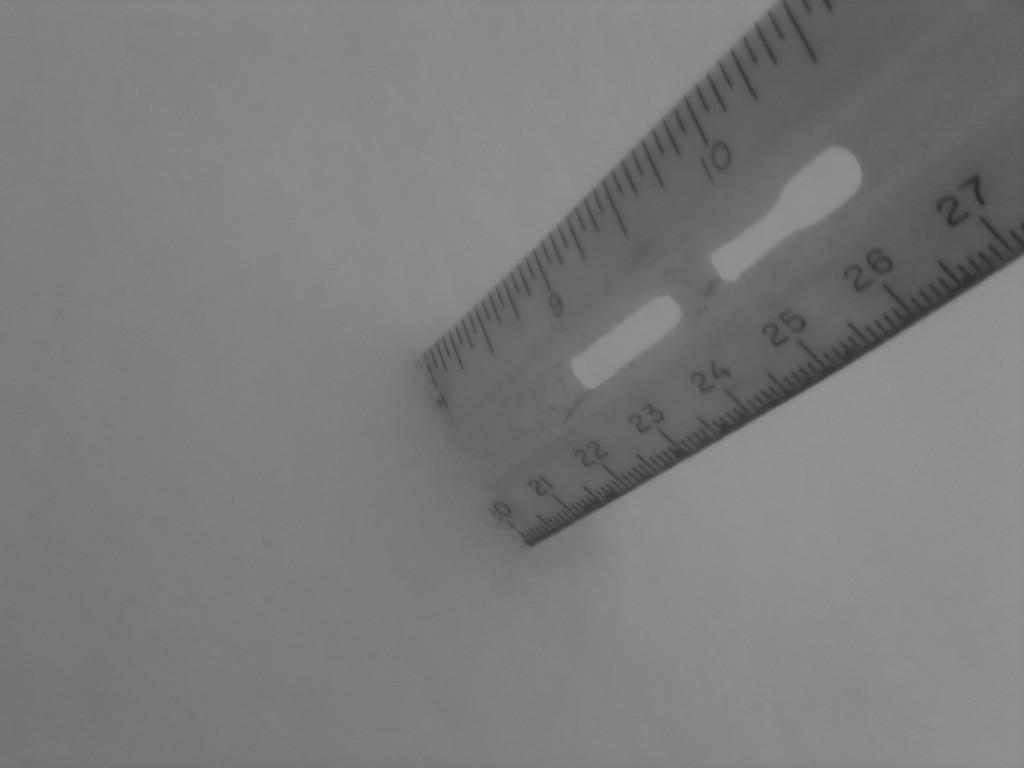<image>
Give a short and clear explanation of the subsequent image. Ruler that ends at 10 standing upright on a platform. 